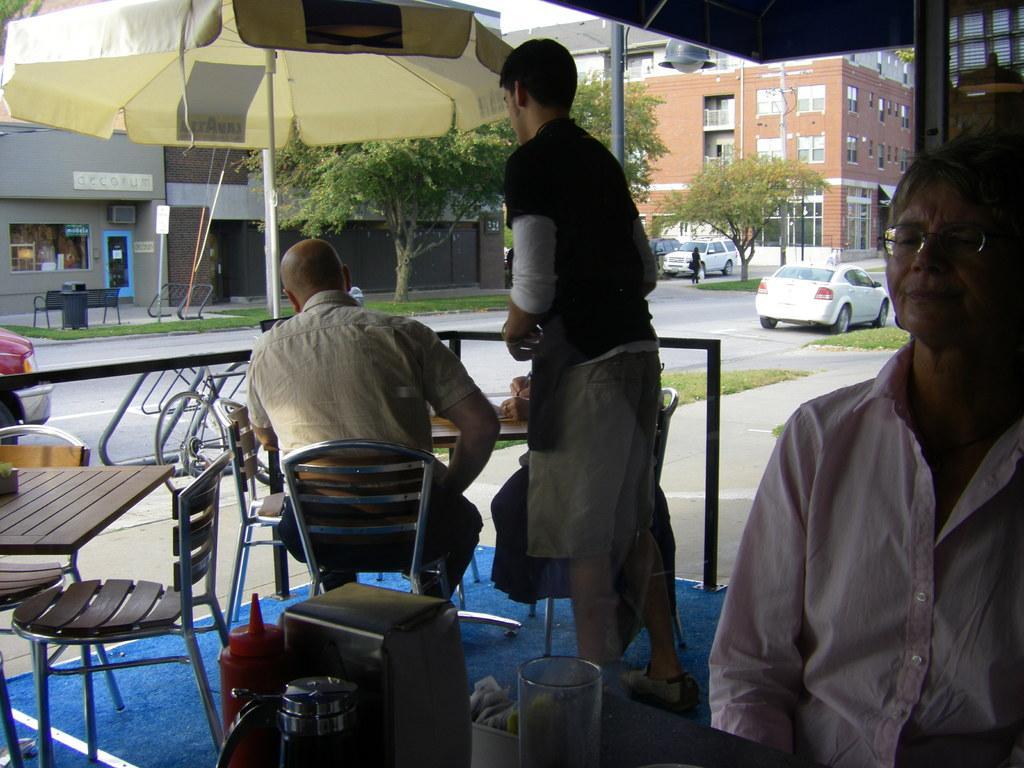Can you describe this image briefly? In this image we can see the person's, chairs and tables. At the bottom we can see the objects on a table. In the background, we can see the grass, vehicles, trees, buildings and a pole with light. At the top we can see the sky. 